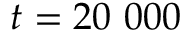Convert formula to latex. <formula><loc_0><loc_0><loc_500><loc_500>t = 2 0 \ 0 0 0</formula> 